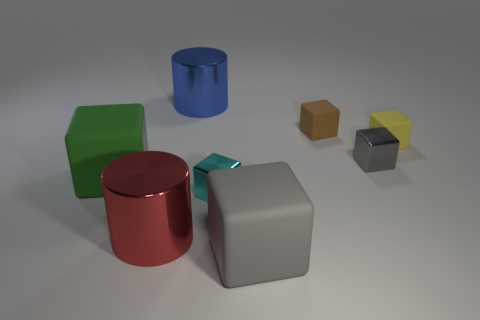Are there any other things that have the same shape as the cyan shiny object?
Offer a very short reply. Yes. There is a large matte block that is to the right of the big blue cylinder; is its color the same as the small metal object that is behind the small cyan metallic object?
Offer a terse response. Yes. Does the big cylinder in front of the big blue thing have the same material as the gray cube on the left side of the brown rubber thing?
Keep it short and to the point. No. There is a large matte object that is in front of the green block; is it the same shape as the rubber object that is behind the small yellow block?
Offer a very short reply. Yes. Are there any blue things that have the same material as the small gray thing?
Provide a short and direct response. Yes. There is a gray cube that is the same size as the blue cylinder; what material is it?
Keep it short and to the point. Rubber. Do the small brown block and the green block have the same material?
Give a very brief answer. Yes. How many objects are either tiny shiny blocks or tiny yellow rubber objects?
Your response must be concise. 3. What shape is the tiny rubber thing in front of the brown thing?
Your answer should be very brief. Cube. What is the color of the other large cylinder that is the same material as the large blue cylinder?
Give a very brief answer. Red. 